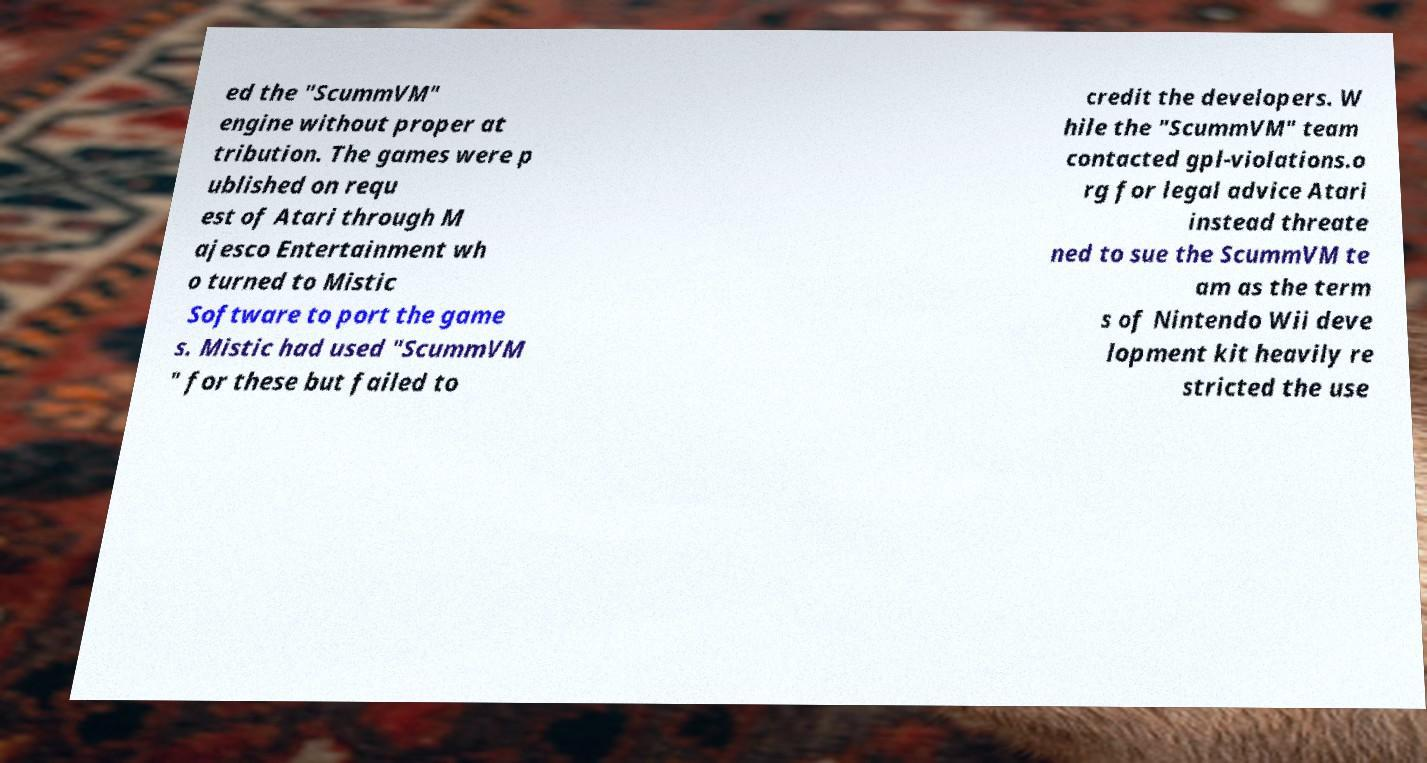I need the written content from this picture converted into text. Can you do that? ed the "ScummVM" engine without proper at tribution. The games were p ublished on requ est of Atari through M ajesco Entertainment wh o turned to Mistic Software to port the game s. Mistic had used "ScummVM " for these but failed to credit the developers. W hile the "ScummVM" team contacted gpl-violations.o rg for legal advice Atari instead threate ned to sue the ScummVM te am as the term s of Nintendo Wii deve lopment kit heavily re stricted the use 